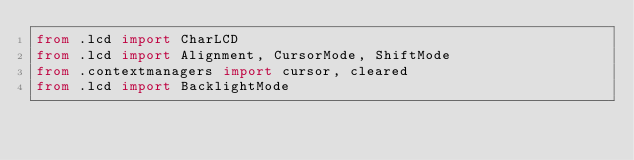<code> <loc_0><loc_0><loc_500><loc_500><_Python_>from .lcd import CharLCD
from .lcd import Alignment, CursorMode, ShiftMode
from .contextmanagers import cursor, cleared
from .lcd import BacklightMode

</code> 